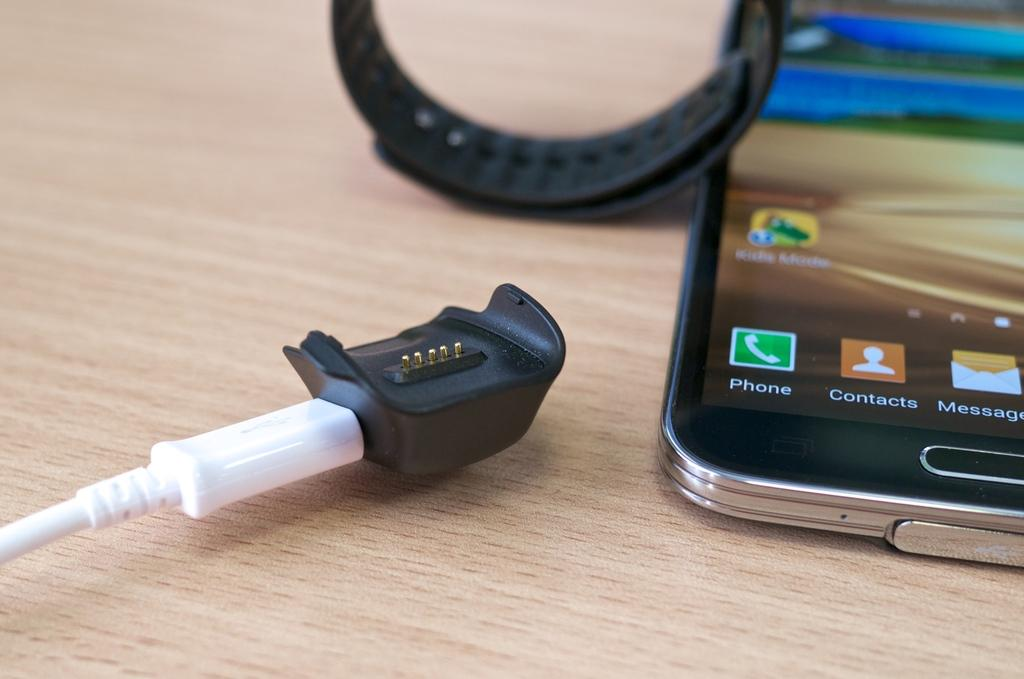Provide a one-sentence caption for the provided image. Phone, Contacts and Messages are shown as icons on this smart phone. 